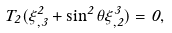Convert formula to latex. <formula><loc_0><loc_0><loc_500><loc_500>T _ { 2 } ( \xi ^ { 2 } _ { , 3 } + \sin ^ { 2 } \theta \xi ^ { 3 } _ { , 2 } ) = 0 ,</formula> 